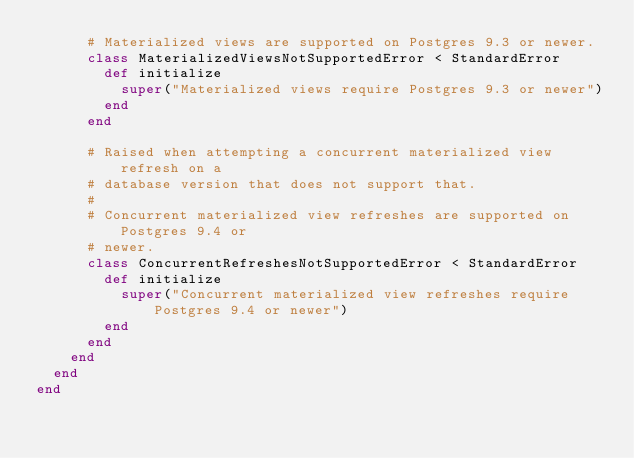Convert code to text. <code><loc_0><loc_0><loc_500><loc_500><_Ruby_>      # Materialized views are supported on Postgres 9.3 or newer.
      class MaterializedViewsNotSupportedError < StandardError
        def initialize
          super("Materialized views require Postgres 9.3 or newer")
        end
      end

      # Raised when attempting a concurrent materialized view refresh on a
      # database version that does not support that.
      #
      # Concurrent materialized view refreshes are supported on Postgres 9.4 or
      # newer.
      class ConcurrentRefreshesNotSupportedError < StandardError
        def initialize
          super("Concurrent materialized view refreshes require Postgres 9.4 or newer")
        end
      end
    end
  end
end
</code> 